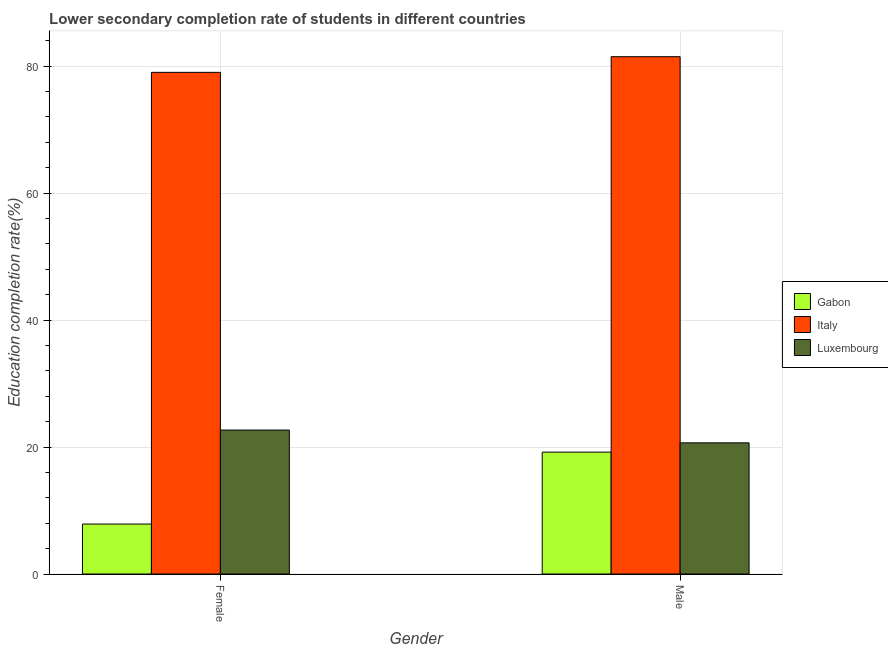What is the education completion rate of female students in Italy?
Provide a succinct answer. 79.03. Across all countries, what is the maximum education completion rate of female students?
Give a very brief answer. 79.03. Across all countries, what is the minimum education completion rate of female students?
Ensure brevity in your answer.  7.87. In which country was the education completion rate of male students minimum?
Provide a short and direct response. Gabon. What is the total education completion rate of male students in the graph?
Your answer should be compact. 121.36. What is the difference between the education completion rate of male students in Italy and that in Luxembourg?
Offer a terse response. 60.84. What is the difference between the education completion rate of female students in Luxembourg and the education completion rate of male students in Italy?
Your response must be concise. -58.82. What is the average education completion rate of female students per country?
Your answer should be compact. 36.53. What is the difference between the education completion rate of male students and education completion rate of female students in Luxembourg?
Offer a very short reply. -2.02. What is the ratio of the education completion rate of male students in Italy to that in Gabon?
Your answer should be compact. 4.24. Is the education completion rate of male students in Italy less than that in Gabon?
Give a very brief answer. No. In how many countries, is the education completion rate of female students greater than the average education completion rate of female students taken over all countries?
Keep it short and to the point. 1. What does the 1st bar from the left in Male represents?
Your answer should be very brief. Gabon. What does the 3rd bar from the right in Female represents?
Keep it short and to the point. Gabon. Are all the bars in the graph horizontal?
Make the answer very short. No. How many countries are there in the graph?
Your answer should be very brief. 3. How many legend labels are there?
Keep it short and to the point. 3. How are the legend labels stacked?
Your answer should be compact. Vertical. What is the title of the graph?
Make the answer very short. Lower secondary completion rate of students in different countries. Does "St. Lucia" appear as one of the legend labels in the graph?
Provide a short and direct response. No. What is the label or title of the Y-axis?
Your answer should be compact. Education completion rate(%). What is the Education completion rate(%) of Gabon in Female?
Your answer should be very brief. 7.87. What is the Education completion rate(%) in Italy in Female?
Provide a succinct answer. 79.03. What is the Education completion rate(%) in Luxembourg in Female?
Your answer should be very brief. 22.68. What is the Education completion rate(%) of Gabon in Male?
Keep it short and to the point. 19.2. What is the Education completion rate(%) of Italy in Male?
Keep it short and to the point. 81.5. What is the Education completion rate(%) in Luxembourg in Male?
Provide a succinct answer. 20.66. Across all Gender, what is the maximum Education completion rate(%) in Gabon?
Offer a terse response. 19.2. Across all Gender, what is the maximum Education completion rate(%) in Italy?
Keep it short and to the point. 81.5. Across all Gender, what is the maximum Education completion rate(%) of Luxembourg?
Your answer should be very brief. 22.68. Across all Gender, what is the minimum Education completion rate(%) in Gabon?
Make the answer very short. 7.87. Across all Gender, what is the minimum Education completion rate(%) of Italy?
Make the answer very short. 79.03. Across all Gender, what is the minimum Education completion rate(%) in Luxembourg?
Make the answer very short. 20.66. What is the total Education completion rate(%) in Gabon in the graph?
Offer a terse response. 27.07. What is the total Education completion rate(%) of Italy in the graph?
Offer a very short reply. 160.53. What is the total Education completion rate(%) of Luxembourg in the graph?
Your answer should be very brief. 43.34. What is the difference between the Education completion rate(%) of Gabon in Female and that in Male?
Keep it short and to the point. -11.33. What is the difference between the Education completion rate(%) of Italy in Female and that in Male?
Offer a very short reply. -2.47. What is the difference between the Education completion rate(%) in Luxembourg in Female and that in Male?
Ensure brevity in your answer.  2.02. What is the difference between the Education completion rate(%) of Gabon in Female and the Education completion rate(%) of Italy in Male?
Keep it short and to the point. -73.63. What is the difference between the Education completion rate(%) in Gabon in Female and the Education completion rate(%) in Luxembourg in Male?
Offer a terse response. -12.79. What is the difference between the Education completion rate(%) in Italy in Female and the Education completion rate(%) in Luxembourg in Male?
Your answer should be very brief. 58.37. What is the average Education completion rate(%) of Gabon per Gender?
Your answer should be very brief. 13.53. What is the average Education completion rate(%) of Italy per Gender?
Offer a terse response. 80.26. What is the average Education completion rate(%) of Luxembourg per Gender?
Your answer should be compact. 21.67. What is the difference between the Education completion rate(%) of Gabon and Education completion rate(%) of Italy in Female?
Offer a very short reply. -71.16. What is the difference between the Education completion rate(%) in Gabon and Education completion rate(%) in Luxembourg in Female?
Your answer should be very brief. -14.81. What is the difference between the Education completion rate(%) of Italy and Education completion rate(%) of Luxembourg in Female?
Your answer should be very brief. 56.35. What is the difference between the Education completion rate(%) of Gabon and Education completion rate(%) of Italy in Male?
Ensure brevity in your answer.  -62.3. What is the difference between the Education completion rate(%) in Gabon and Education completion rate(%) in Luxembourg in Male?
Your answer should be very brief. -1.46. What is the difference between the Education completion rate(%) in Italy and Education completion rate(%) in Luxembourg in Male?
Make the answer very short. 60.84. What is the ratio of the Education completion rate(%) in Gabon in Female to that in Male?
Provide a succinct answer. 0.41. What is the ratio of the Education completion rate(%) of Italy in Female to that in Male?
Offer a terse response. 0.97. What is the ratio of the Education completion rate(%) of Luxembourg in Female to that in Male?
Your answer should be compact. 1.1. What is the difference between the highest and the second highest Education completion rate(%) of Gabon?
Make the answer very short. 11.33. What is the difference between the highest and the second highest Education completion rate(%) of Italy?
Your response must be concise. 2.47. What is the difference between the highest and the second highest Education completion rate(%) of Luxembourg?
Your response must be concise. 2.02. What is the difference between the highest and the lowest Education completion rate(%) in Gabon?
Offer a very short reply. 11.33. What is the difference between the highest and the lowest Education completion rate(%) in Italy?
Offer a very short reply. 2.47. What is the difference between the highest and the lowest Education completion rate(%) in Luxembourg?
Your answer should be compact. 2.02. 